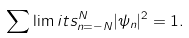<formula> <loc_0><loc_0><loc_500><loc_500>\sum \lim i t s _ { n = - N } ^ { N } | \psi _ { n } | ^ { 2 } = 1 .</formula> 